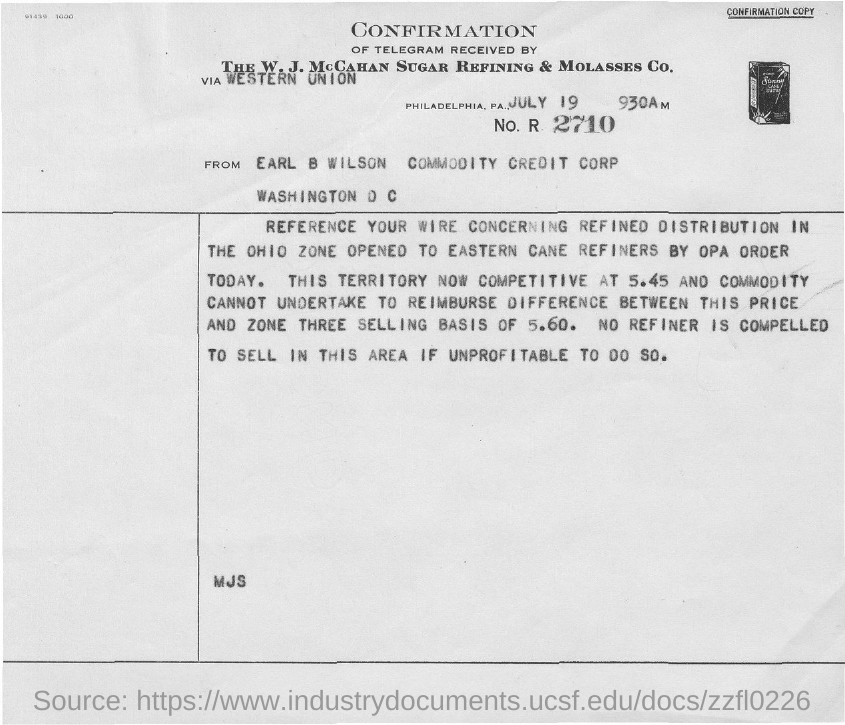What is the Date?
Offer a terse response. July 19. 